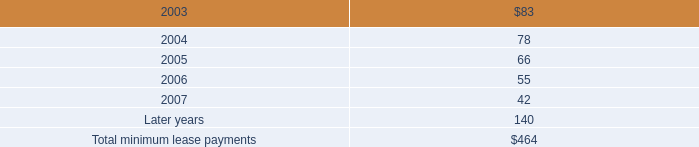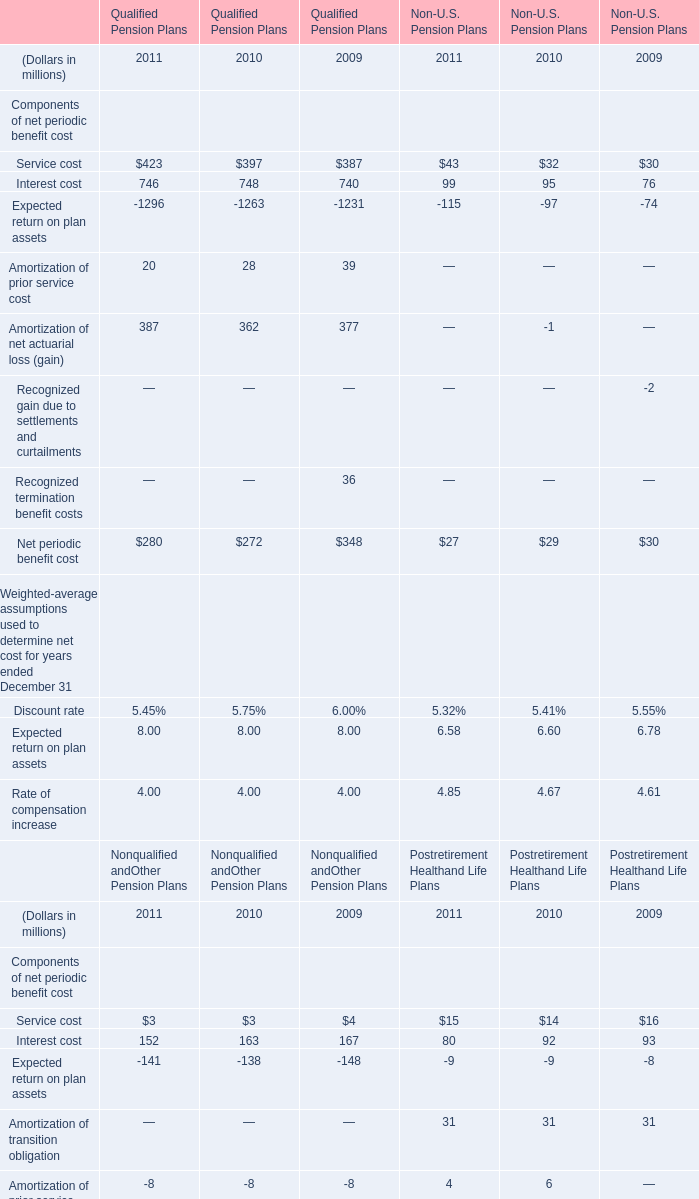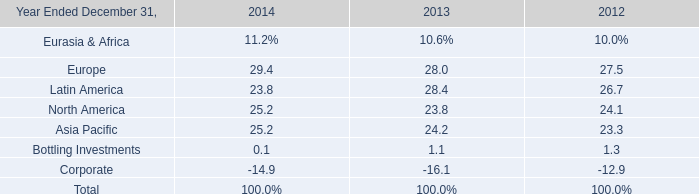Which year is Amortization of net actuarial loss (gain) in Qualified Pension Plans the least? 
Answer: 2010. 